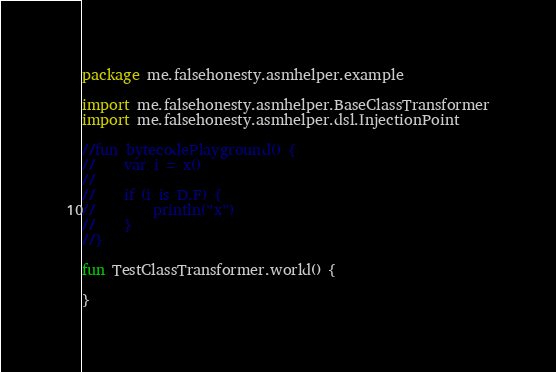<code> <loc_0><loc_0><loc_500><loc_500><_Kotlin_>package me.falsehonesty.asmhelper.example

import me.falsehonesty.asmhelper.BaseClassTransformer
import me.falsehonesty.asmhelper.dsl.InjectionPoint

//fun bytecodePlayground() {
//    var i = x()
//
//    if (i is D.F) {
//        println("x")
//    }
//}

fun TestClassTransformer.world() {

}</code> 